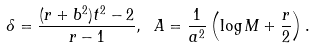<formula> <loc_0><loc_0><loc_500><loc_500>\delta = \frac { ( r + b ^ { 2 } ) t ^ { 2 } - 2 } { r - 1 } , \ A = \frac { 1 } { a ^ { 2 } } \left ( \log M + \frac { r } { 2 } \right ) .</formula> 